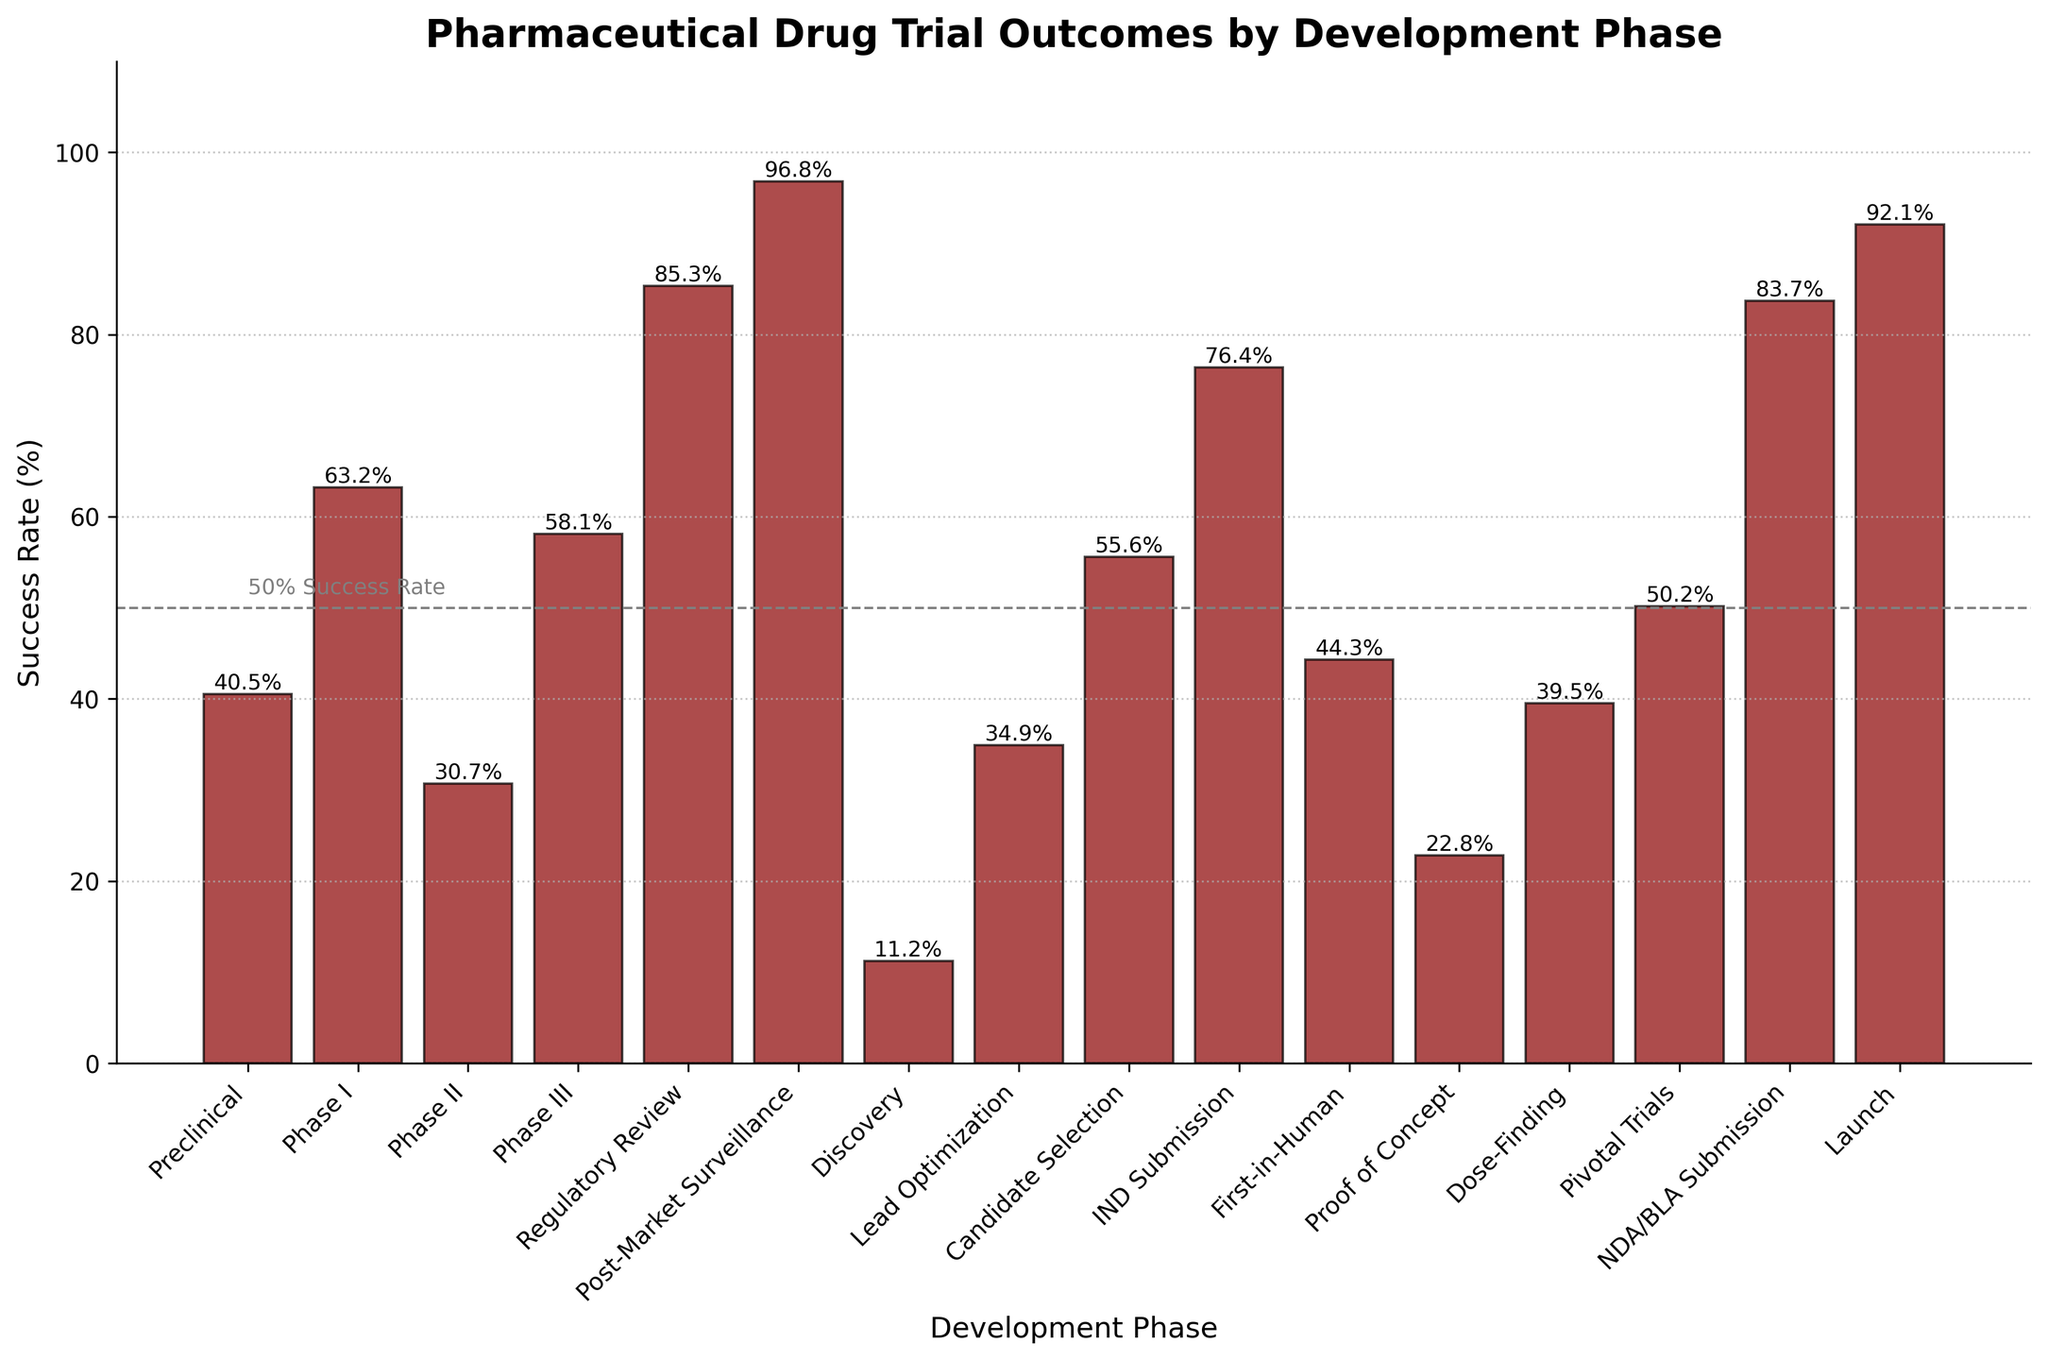Which development phase has the highest success rate? Look at the heights of the bars and identify the tallest one, which represents the "Post-Market Surveillance" phase.
Answer: Post-Market Surveillance Which development phase has the lowest success rate? Identify the shortest bar in the figure, which corresponds to the "Discovery" phase.
Answer: Discovery How does the success rate in Phase III compare to that in Phase I? Compare the heights of the bars for Phase III and Phase I. Phase III has a lower success rate (58.1%) compared to Phase I (63.2%).
Answer: Lower What is the combined success rate of Lead Optimization and Candidate Selection? Add the success rates of Lead Optimization (34.9%) and Candidate Selection (55.6%). 34.9 + 55.6 = 90.5
Answer: 90.5% Which development phase has a success rate closest to 50%? Find the bars with success rates close to 50%. The "Pivotal Trials" phase has a success rate of 50.2%, which is the closest to 50%.
Answer: Pivotal Trials Which development phases have success rates higher than 80%? Identify all bars with heights corresponding to success rates over 80%. These phases are "Regulatory Review" (85.3%), "NDA/BLA Submission" (83.7%), "Post-Market Surveillance" (96.8%), and "Launch" (92.1%).
Answer: Regulatory Review, NDA/BLA Submission, Post-Market Surveillance, Launch What is the average success rate of the phases with success rates below 50%? Identify phases with success rates below 50%: Discovery (11.2%), Preclinical (40.5%), Lead Optimization (34.9%), First-in-Human (44.3%), Proof of Concept (22.8%), and Dose-Finding (39.5%). Compute their average: (11.2 + 40.5 + 34.9 + 44.3 + 22.8 + 39.5) / 6 = 32.2%
Answer: 32.2% By how much does the success rate of IND Submission exceed that of Preclinical? Subtract the success rate of Preclinical (40.5%) from IND Submission (76.4%). 76.4 - 40.5 = 35.9
Answer: 35.9% What is the difference in success rate between Proof of Concept and Dose-Finding phases? Subtract the success rate of Proof of Concept (22.8%) from Dose-Finding (39.5%). 39.5 - 22.8 = 16.7
Answer: 16.7% How many phases have success rates higher than 60%? Count the number of bars with heights exceeding 60%. The phases that satisfy this condition are Phase I (63.2%), IND Submission (76.4%), Regulatory Review (85.3%), NDA/BLA Submission (83.7%), Launch (92.1%), and Post-Market Surveillance (96.8%), adding up to 6 phases.
Answer: 6 